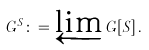Convert formula to latex. <formula><loc_0><loc_0><loc_500><loc_500>G ^ { S } \colon = \varprojlim G [ S ] \, .</formula> 